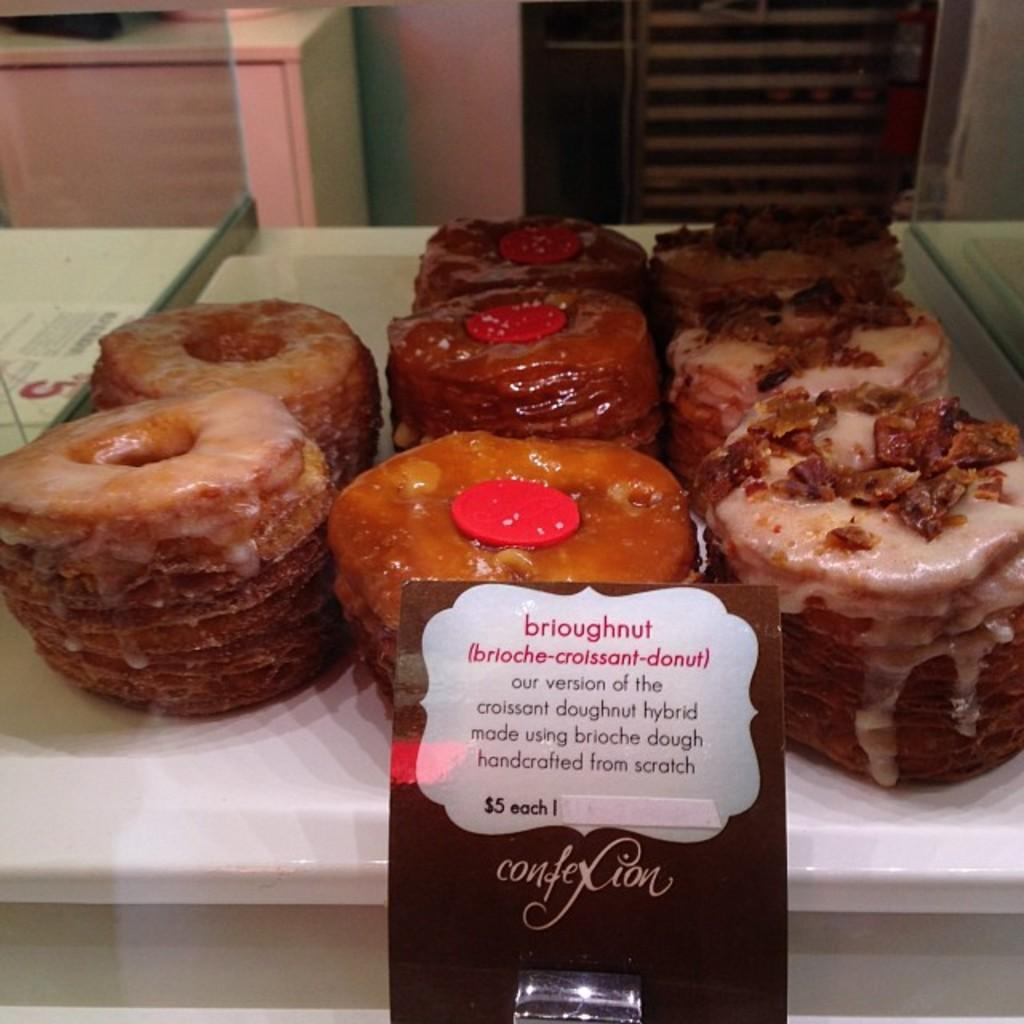What type of food is present on the table in the image? There are bread pieces on the table. Is there any additional information provided about the food? Yes, there is a paper attached to the food. What can be seen in the background of the image? The wall is visible at the top of the image. How many beds are visible in the image? There are no beds present in the image. What type of reward is being given to the bread pieces in the image? There is no reward being given to the bread pieces in the image, as the paper attached to the food is not described as a reward. 